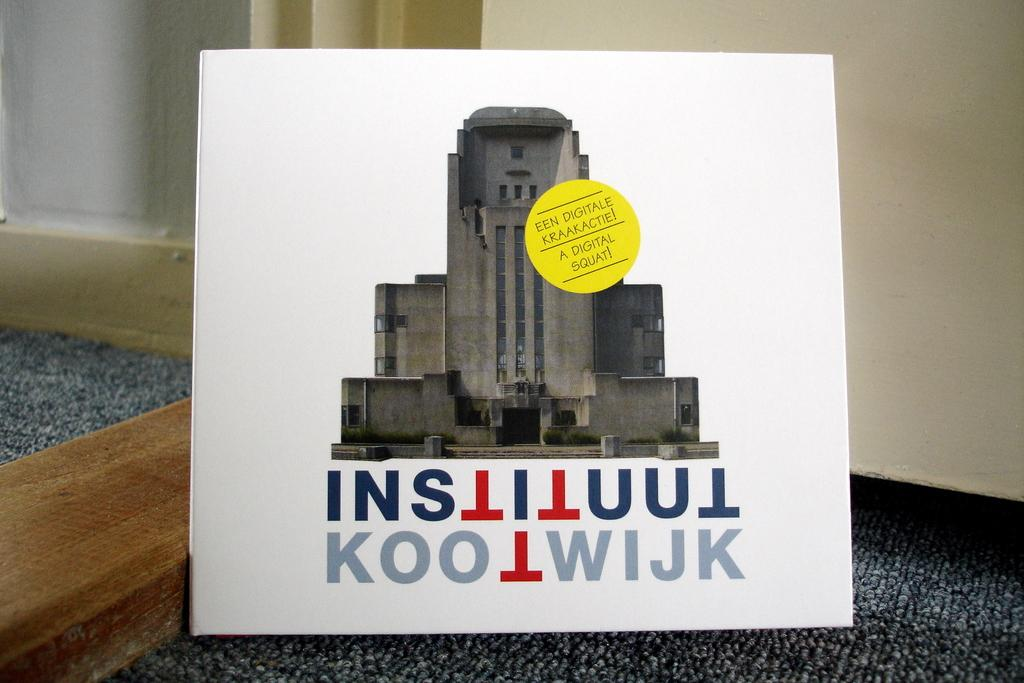What type of object related to a university can be seen in the image? The object related to a university in the image is not specified, but it is present. Where is the university-related object located in the image? The object is placed on the floor. Can you see any caves or dolls in the image? No, there are no caves or dolls present in the image. 